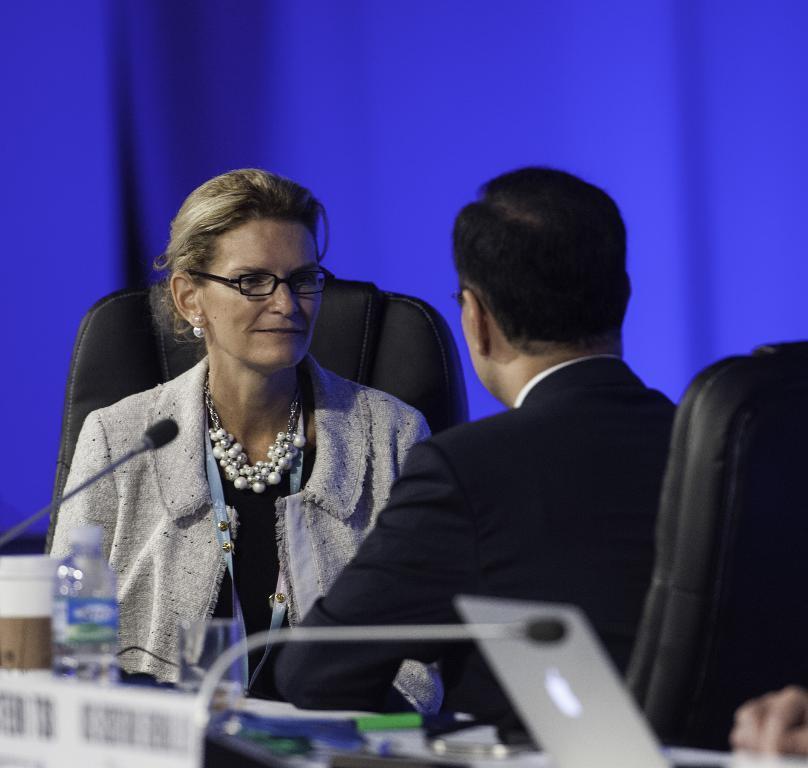In one or two sentences, can you explain what this image depicts? In this picture I can see two persons sitting on the cars, there are miles, a water bottle, glass, paper cup, laptop and some other items on the table, and there is blue background. 